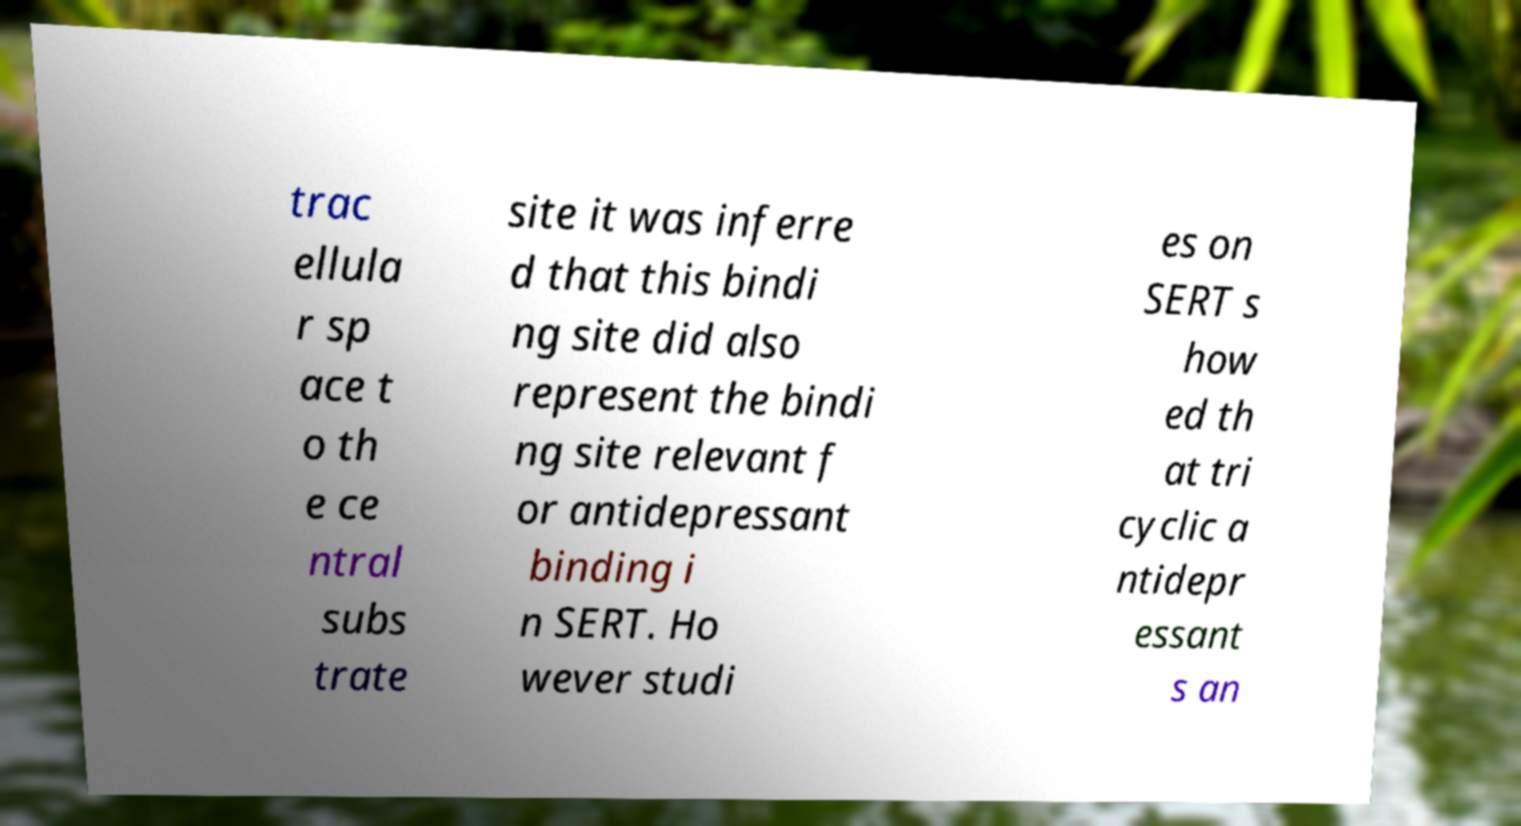Please identify and transcribe the text found in this image. trac ellula r sp ace t o th e ce ntral subs trate site it was inferre d that this bindi ng site did also represent the bindi ng site relevant f or antidepressant binding i n SERT. Ho wever studi es on SERT s how ed th at tri cyclic a ntidepr essant s an 